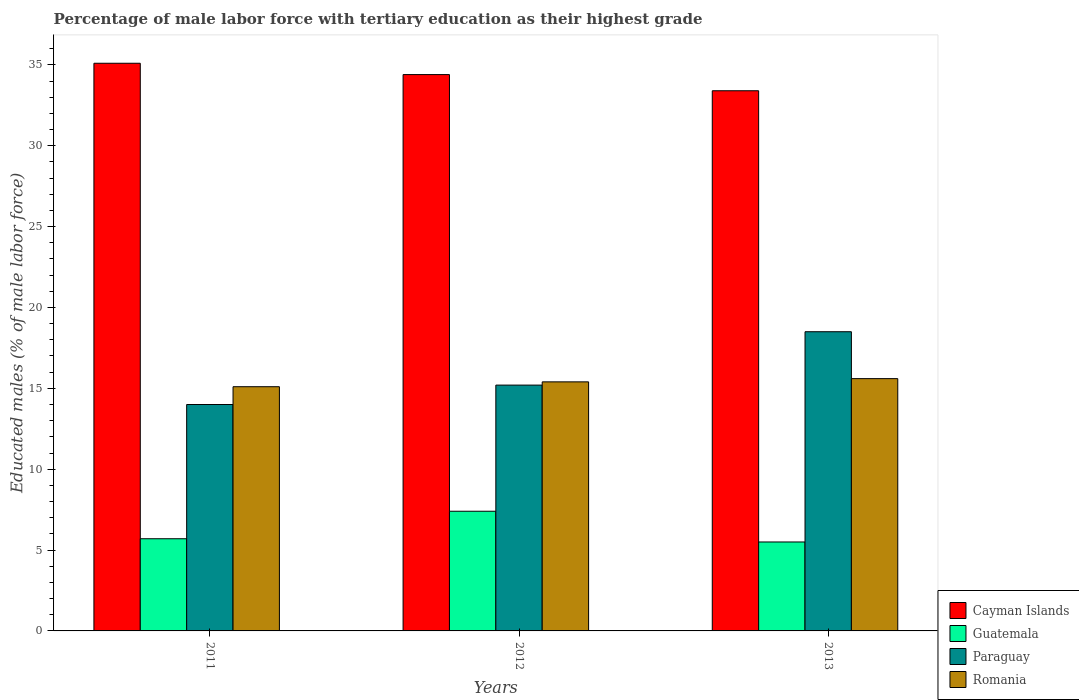How many different coloured bars are there?
Your answer should be very brief. 4. How many groups of bars are there?
Ensure brevity in your answer.  3. How many bars are there on the 3rd tick from the left?
Your answer should be very brief. 4. How many bars are there on the 2nd tick from the right?
Keep it short and to the point. 4. What is the label of the 1st group of bars from the left?
Ensure brevity in your answer.  2011. In how many cases, is the number of bars for a given year not equal to the number of legend labels?
Offer a very short reply. 0. What is the percentage of male labor force with tertiary education in Romania in 2013?
Ensure brevity in your answer.  15.6. Across all years, what is the maximum percentage of male labor force with tertiary education in Guatemala?
Provide a short and direct response. 7.4. Across all years, what is the minimum percentage of male labor force with tertiary education in Guatemala?
Keep it short and to the point. 5.5. In which year was the percentage of male labor force with tertiary education in Guatemala maximum?
Your response must be concise. 2012. In which year was the percentage of male labor force with tertiary education in Cayman Islands minimum?
Your answer should be very brief. 2013. What is the total percentage of male labor force with tertiary education in Paraguay in the graph?
Provide a succinct answer. 47.7. What is the difference between the percentage of male labor force with tertiary education in Romania in 2012 and that in 2013?
Your response must be concise. -0.2. What is the difference between the percentage of male labor force with tertiary education in Paraguay in 2011 and the percentage of male labor force with tertiary education in Guatemala in 2013?
Your answer should be very brief. 8.5. What is the average percentage of male labor force with tertiary education in Paraguay per year?
Offer a very short reply. 15.9. In the year 2011, what is the difference between the percentage of male labor force with tertiary education in Cayman Islands and percentage of male labor force with tertiary education in Paraguay?
Your answer should be very brief. 21.1. What is the ratio of the percentage of male labor force with tertiary education in Guatemala in 2011 to that in 2013?
Give a very brief answer. 1.04. Is the percentage of male labor force with tertiary education in Cayman Islands in 2012 less than that in 2013?
Your answer should be very brief. No. Is the difference between the percentage of male labor force with tertiary education in Cayman Islands in 2011 and 2013 greater than the difference between the percentage of male labor force with tertiary education in Paraguay in 2011 and 2013?
Give a very brief answer. Yes. What is the difference between the highest and the second highest percentage of male labor force with tertiary education in Romania?
Offer a very short reply. 0.2. What is the difference between the highest and the lowest percentage of male labor force with tertiary education in Guatemala?
Provide a succinct answer. 1.9. In how many years, is the percentage of male labor force with tertiary education in Cayman Islands greater than the average percentage of male labor force with tertiary education in Cayman Islands taken over all years?
Provide a short and direct response. 2. Is the sum of the percentage of male labor force with tertiary education in Romania in 2011 and 2012 greater than the maximum percentage of male labor force with tertiary education in Paraguay across all years?
Provide a short and direct response. Yes. What does the 4th bar from the left in 2012 represents?
Give a very brief answer. Romania. What does the 4th bar from the right in 2011 represents?
Your answer should be compact. Cayman Islands. Is it the case that in every year, the sum of the percentage of male labor force with tertiary education in Paraguay and percentage of male labor force with tertiary education in Guatemala is greater than the percentage of male labor force with tertiary education in Romania?
Offer a terse response. Yes. How many bars are there?
Provide a succinct answer. 12. Are all the bars in the graph horizontal?
Offer a very short reply. No. Does the graph contain any zero values?
Your answer should be compact. No. How many legend labels are there?
Keep it short and to the point. 4. What is the title of the graph?
Keep it short and to the point. Percentage of male labor force with tertiary education as their highest grade. What is the label or title of the Y-axis?
Ensure brevity in your answer.  Educated males (% of male labor force). What is the Educated males (% of male labor force) in Cayman Islands in 2011?
Your answer should be compact. 35.1. What is the Educated males (% of male labor force) in Guatemala in 2011?
Your answer should be compact. 5.7. What is the Educated males (% of male labor force) of Paraguay in 2011?
Provide a short and direct response. 14. What is the Educated males (% of male labor force) of Romania in 2011?
Keep it short and to the point. 15.1. What is the Educated males (% of male labor force) in Cayman Islands in 2012?
Offer a very short reply. 34.4. What is the Educated males (% of male labor force) of Guatemala in 2012?
Offer a very short reply. 7.4. What is the Educated males (% of male labor force) of Paraguay in 2012?
Make the answer very short. 15.2. What is the Educated males (% of male labor force) of Romania in 2012?
Make the answer very short. 15.4. What is the Educated males (% of male labor force) in Cayman Islands in 2013?
Your response must be concise. 33.4. What is the Educated males (% of male labor force) of Paraguay in 2013?
Ensure brevity in your answer.  18.5. What is the Educated males (% of male labor force) in Romania in 2013?
Offer a terse response. 15.6. Across all years, what is the maximum Educated males (% of male labor force) in Cayman Islands?
Keep it short and to the point. 35.1. Across all years, what is the maximum Educated males (% of male labor force) of Guatemala?
Your answer should be compact. 7.4. Across all years, what is the maximum Educated males (% of male labor force) of Romania?
Provide a succinct answer. 15.6. Across all years, what is the minimum Educated males (% of male labor force) of Cayman Islands?
Offer a very short reply. 33.4. Across all years, what is the minimum Educated males (% of male labor force) of Guatemala?
Ensure brevity in your answer.  5.5. Across all years, what is the minimum Educated males (% of male labor force) in Paraguay?
Provide a short and direct response. 14. Across all years, what is the minimum Educated males (% of male labor force) of Romania?
Your answer should be compact. 15.1. What is the total Educated males (% of male labor force) in Cayman Islands in the graph?
Your response must be concise. 102.9. What is the total Educated males (% of male labor force) in Paraguay in the graph?
Offer a very short reply. 47.7. What is the total Educated males (% of male labor force) in Romania in the graph?
Provide a succinct answer. 46.1. What is the difference between the Educated males (% of male labor force) in Paraguay in 2011 and that in 2012?
Your response must be concise. -1.2. What is the difference between the Educated males (% of male labor force) in Romania in 2012 and that in 2013?
Offer a very short reply. -0.2. What is the difference between the Educated males (% of male labor force) of Cayman Islands in 2011 and the Educated males (% of male labor force) of Guatemala in 2012?
Ensure brevity in your answer.  27.7. What is the difference between the Educated males (% of male labor force) of Guatemala in 2011 and the Educated males (% of male labor force) of Romania in 2012?
Your response must be concise. -9.7. What is the difference between the Educated males (% of male labor force) of Paraguay in 2011 and the Educated males (% of male labor force) of Romania in 2012?
Make the answer very short. -1.4. What is the difference between the Educated males (% of male labor force) in Cayman Islands in 2011 and the Educated males (% of male labor force) in Guatemala in 2013?
Make the answer very short. 29.6. What is the difference between the Educated males (% of male labor force) of Cayman Islands in 2011 and the Educated males (% of male labor force) of Paraguay in 2013?
Give a very brief answer. 16.6. What is the difference between the Educated males (% of male labor force) of Paraguay in 2011 and the Educated males (% of male labor force) of Romania in 2013?
Provide a succinct answer. -1.6. What is the difference between the Educated males (% of male labor force) in Cayman Islands in 2012 and the Educated males (% of male labor force) in Guatemala in 2013?
Keep it short and to the point. 28.9. What is the difference between the Educated males (% of male labor force) in Cayman Islands in 2012 and the Educated males (% of male labor force) in Paraguay in 2013?
Your answer should be compact. 15.9. What is the difference between the Educated males (% of male labor force) in Guatemala in 2012 and the Educated males (% of male labor force) in Paraguay in 2013?
Offer a very short reply. -11.1. What is the difference between the Educated males (% of male labor force) of Guatemala in 2012 and the Educated males (% of male labor force) of Romania in 2013?
Your answer should be very brief. -8.2. What is the average Educated males (% of male labor force) of Cayman Islands per year?
Keep it short and to the point. 34.3. What is the average Educated males (% of male labor force) of Guatemala per year?
Provide a short and direct response. 6.2. What is the average Educated males (% of male labor force) of Paraguay per year?
Your response must be concise. 15.9. What is the average Educated males (% of male labor force) of Romania per year?
Your answer should be compact. 15.37. In the year 2011, what is the difference between the Educated males (% of male labor force) of Cayman Islands and Educated males (% of male labor force) of Guatemala?
Provide a succinct answer. 29.4. In the year 2011, what is the difference between the Educated males (% of male labor force) in Cayman Islands and Educated males (% of male labor force) in Paraguay?
Your answer should be compact. 21.1. In the year 2011, what is the difference between the Educated males (% of male labor force) of Cayman Islands and Educated males (% of male labor force) of Romania?
Ensure brevity in your answer.  20. In the year 2011, what is the difference between the Educated males (% of male labor force) in Paraguay and Educated males (% of male labor force) in Romania?
Your answer should be very brief. -1.1. In the year 2012, what is the difference between the Educated males (% of male labor force) in Cayman Islands and Educated males (% of male labor force) in Guatemala?
Your answer should be compact. 27. In the year 2012, what is the difference between the Educated males (% of male labor force) in Cayman Islands and Educated males (% of male labor force) in Paraguay?
Provide a short and direct response. 19.2. In the year 2012, what is the difference between the Educated males (% of male labor force) of Cayman Islands and Educated males (% of male labor force) of Romania?
Provide a short and direct response. 19. In the year 2012, what is the difference between the Educated males (% of male labor force) of Guatemala and Educated males (% of male labor force) of Paraguay?
Your response must be concise. -7.8. In the year 2012, what is the difference between the Educated males (% of male labor force) of Guatemala and Educated males (% of male labor force) of Romania?
Offer a terse response. -8. In the year 2013, what is the difference between the Educated males (% of male labor force) in Cayman Islands and Educated males (% of male labor force) in Guatemala?
Make the answer very short. 27.9. In the year 2013, what is the difference between the Educated males (% of male labor force) in Cayman Islands and Educated males (% of male labor force) in Paraguay?
Offer a terse response. 14.9. In the year 2013, what is the difference between the Educated males (% of male labor force) of Cayman Islands and Educated males (% of male labor force) of Romania?
Offer a very short reply. 17.8. In the year 2013, what is the difference between the Educated males (% of male labor force) of Guatemala and Educated males (% of male labor force) of Paraguay?
Keep it short and to the point. -13. In the year 2013, what is the difference between the Educated males (% of male labor force) of Guatemala and Educated males (% of male labor force) of Romania?
Your response must be concise. -10.1. In the year 2013, what is the difference between the Educated males (% of male labor force) of Paraguay and Educated males (% of male labor force) of Romania?
Make the answer very short. 2.9. What is the ratio of the Educated males (% of male labor force) of Cayman Islands in 2011 to that in 2012?
Ensure brevity in your answer.  1.02. What is the ratio of the Educated males (% of male labor force) in Guatemala in 2011 to that in 2012?
Your response must be concise. 0.77. What is the ratio of the Educated males (% of male labor force) of Paraguay in 2011 to that in 2012?
Give a very brief answer. 0.92. What is the ratio of the Educated males (% of male labor force) of Romania in 2011 to that in 2012?
Provide a short and direct response. 0.98. What is the ratio of the Educated males (% of male labor force) of Cayman Islands in 2011 to that in 2013?
Provide a short and direct response. 1.05. What is the ratio of the Educated males (% of male labor force) in Guatemala in 2011 to that in 2013?
Offer a terse response. 1.04. What is the ratio of the Educated males (% of male labor force) of Paraguay in 2011 to that in 2013?
Keep it short and to the point. 0.76. What is the ratio of the Educated males (% of male labor force) of Romania in 2011 to that in 2013?
Offer a terse response. 0.97. What is the ratio of the Educated males (% of male labor force) in Cayman Islands in 2012 to that in 2013?
Offer a terse response. 1.03. What is the ratio of the Educated males (% of male labor force) of Guatemala in 2012 to that in 2013?
Offer a very short reply. 1.35. What is the ratio of the Educated males (% of male labor force) of Paraguay in 2012 to that in 2013?
Your answer should be very brief. 0.82. What is the ratio of the Educated males (% of male labor force) of Romania in 2012 to that in 2013?
Offer a terse response. 0.99. What is the difference between the highest and the second highest Educated males (% of male labor force) of Guatemala?
Offer a terse response. 1.7. What is the difference between the highest and the second highest Educated males (% of male labor force) in Paraguay?
Your answer should be compact. 3.3. What is the difference between the highest and the lowest Educated males (% of male labor force) of Cayman Islands?
Your answer should be very brief. 1.7. What is the difference between the highest and the lowest Educated males (% of male labor force) of Guatemala?
Give a very brief answer. 1.9. What is the difference between the highest and the lowest Educated males (% of male labor force) of Paraguay?
Your answer should be very brief. 4.5. What is the difference between the highest and the lowest Educated males (% of male labor force) in Romania?
Your response must be concise. 0.5. 